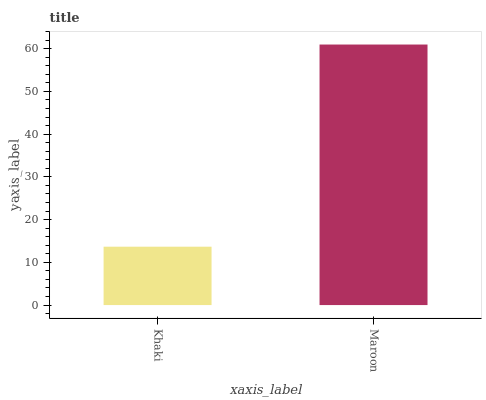Is Khaki the minimum?
Answer yes or no. Yes. Is Maroon the maximum?
Answer yes or no. Yes. Is Maroon the minimum?
Answer yes or no. No. Is Maroon greater than Khaki?
Answer yes or no. Yes. Is Khaki less than Maroon?
Answer yes or no. Yes. Is Khaki greater than Maroon?
Answer yes or no. No. Is Maroon less than Khaki?
Answer yes or no. No. Is Maroon the high median?
Answer yes or no. Yes. Is Khaki the low median?
Answer yes or no. Yes. Is Khaki the high median?
Answer yes or no. No. Is Maroon the low median?
Answer yes or no. No. 